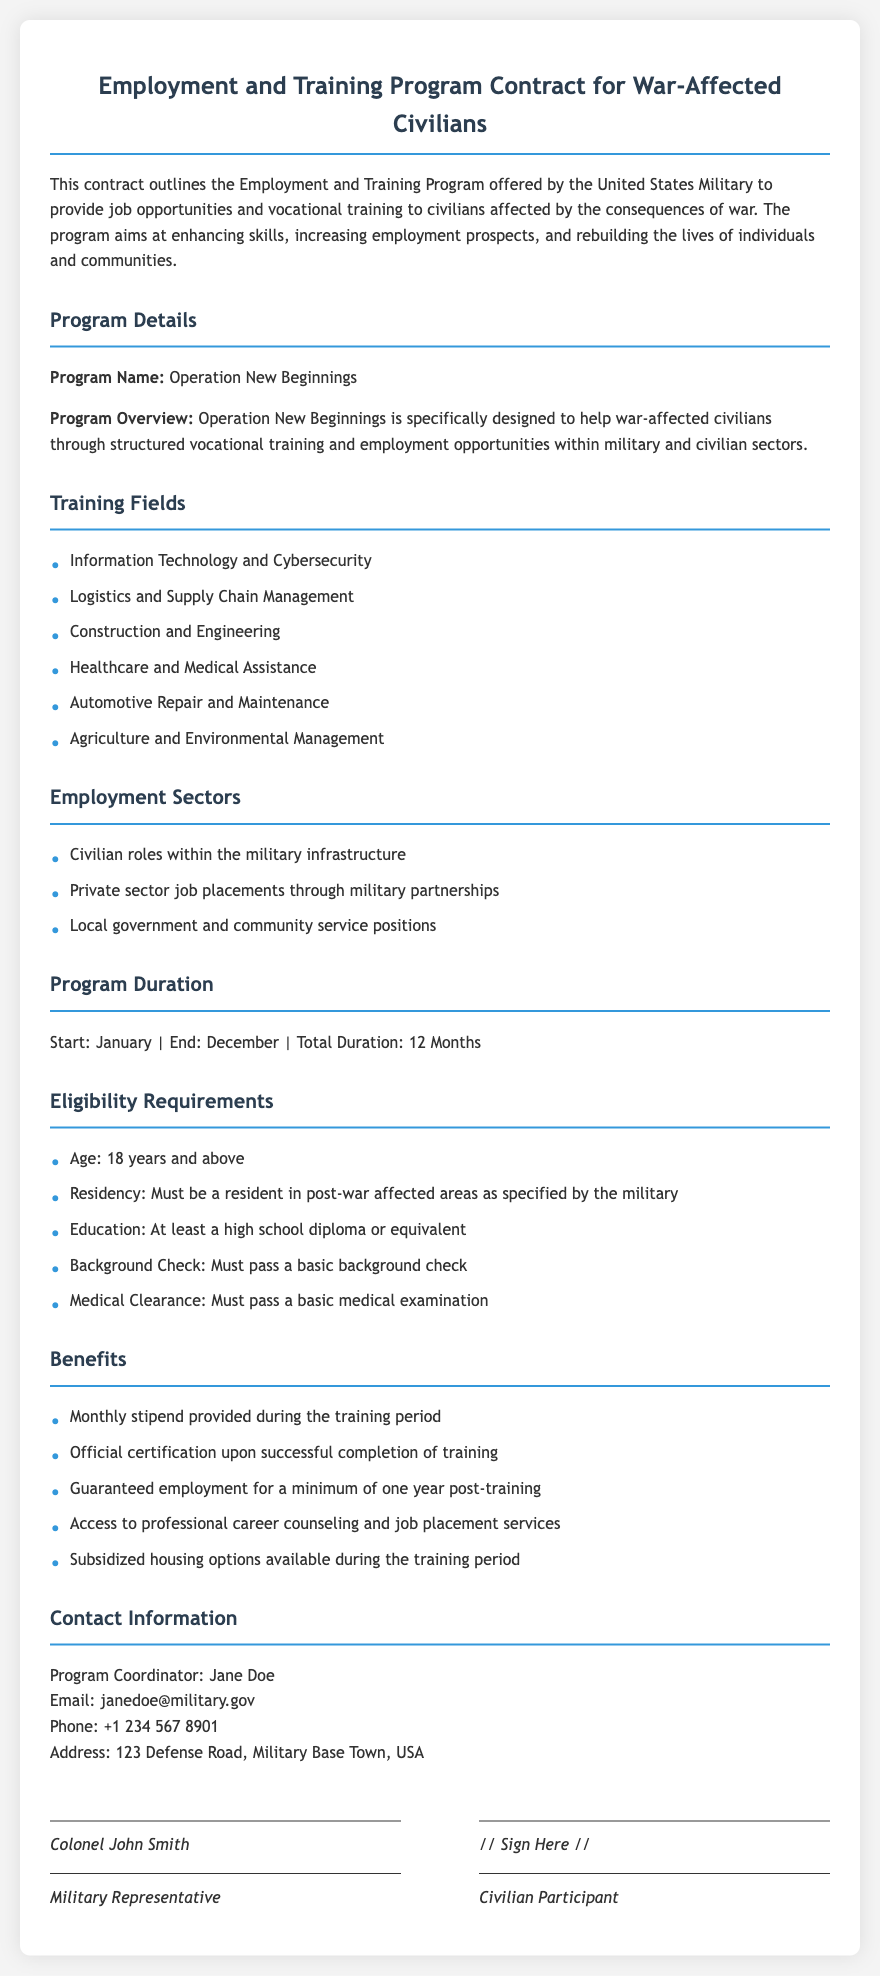what is the program name? The program name is specified in the document under Program Details.
Answer: Operation New Beginnings who is the program coordinator? The program coordinator is listed in the Contact Information section.
Answer: Jane Doe how long does the program last? The total duration of the program is mentioned in the Program Duration section.
Answer: 12 Months what is the minimum age requirement for eligibility? The age requirement is detailed in the Eligibility Requirements section.
Answer: 18 years what type of training fields are offered? The training fields are enumerated in the Training Fields section.
Answer: Information Technology and Cybersecurity, Logistics and Supply Chain Management, Construction and Engineering, Healthcare and Medical Assistance, Automotive Repair and Maintenance, Agriculture and Environmental Management how many benefits are listed in the Benefits section? The total number of benefits can be counted in the Benefits section.
Answer: 5 what are the official certification requirements? The requirements for official certification are outlined in the Benefits section.
Answer: Successful completion of training what is the contact phone number for the program coordinator? The phone number is provided in the Contact Information section.
Answer: +1 234 567 8901 what medical requirement must participants meet? The requirement is indicated in the Eligibility Requirements section.
Answer: Must pass a basic medical examination 